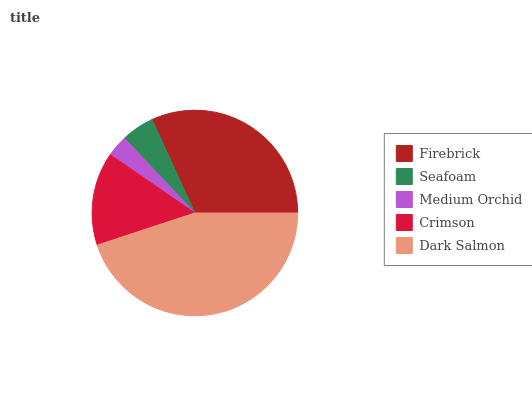Is Medium Orchid the minimum?
Answer yes or no. Yes. Is Dark Salmon the maximum?
Answer yes or no. Yes. Is Seafoam the minimum?
Answer yes or no. No. Is Seafoam the maximum?
Answer yes or no. No. Is Firebrick greater than Seafoam?
Answer yes or no. Yes. Is Seafoam less than Firebrick?
Answer yes or no. Yes. Is Seafoam greater than Firebrick?
Answer yes or no. No. Is Firebrick less than Seafoam?
Answer yes or no. No. Is Crimson the high median?
Answer yes or no. Yes. Is Crimson the low median?
Answer yes or no. Yes. Is Seafoam the high median?
Answer yes or no. No. Is Seafoam the low median?
Answer yes or no. No. 